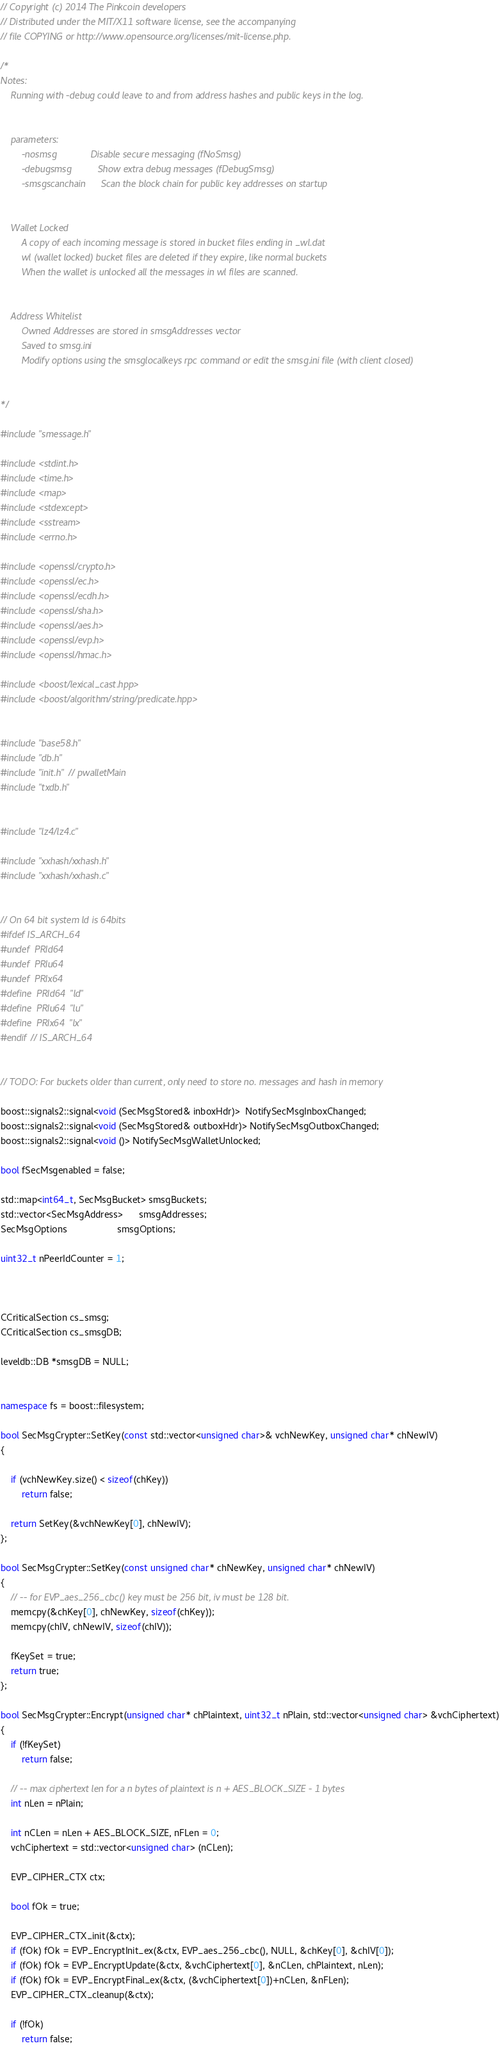<code> <loc_0><loc_0><loc_500><loc_500><_C++_>// Copyright (c) 2014 The Pinkcoin developers
// Distributed under the MIT/X11 software license, see the accompanying
// file COPYING or http://www.opensource.org/licenses/mit-license.php.

/*
Notes:
    Running with -debug could leave to and from address hashes and public keys in the log.
    
    
    parameters:
        -nosmsg             Disable secure messaging (fNoSmsg)
        -debugsmsg          Show extra debug messages (fDebugSmsg)
        -smsgscanchain      Scan the block chain for public key addresses on startup
    
    
    Wallet Locked
        A copy of each incoming message is stored in bucket files ending in _wl.dat
        wl (wallet locked) bucket files are deleted if they expire, like normal buckets
        When the wallet is unlocked all the messages in wl files are scanned.
    
    
    Address Whitelist
        Owned Addresses are stored in smsgAddresses vector
        Saved to smsg.ini
        Modify options using the smsglocalkeys rpc command or edit the smsg.ini file (with client closed)
        
    
*/

#include "smessage.h"

#include <stdint.h>
#include <time.h>
#include <map>
#include <stdexcept>
#include <sstream>
#include <errno.h>

#include <openssl/crypto.h>
#include <openssl/ec.h>
#include <openssl/ecdh.h>
#include <openssl/sha.h>
#include <openssl/aes.h>
#include <openssl/evp.h>
#include <openssl/hmac.h>

#include <boost/lexical_cast.hpp>
#include <boost/algorithm/string/predicate.hpp>


#include "base58.h"
#include "db.h"
#include "init.h" // pwalletMain
#include "txdb.h"


#include "lz4/lz4.c"

#include "xxhash/xxhash.h"
#include "xxhash/xxhash.c"


// On 64 bit system ld is 64bits
#ifdef IS_ARCH_64
#undef  PRId64
#undef  PRIu64
#undef  PRIx64
#define  PRId64  "ld"
#define  PRIu64  "lu"
#define  PRIx64  "lx"
#endif // IS_ARCH_64


// TODO: For buckets older than current, only need to store no. messages and hash in memory

boost::signals2::signal<void (SecMsgStored& inboxHdr)>  NotifySecMsgInboxChanged;
boost::signals2::signal<void (SecMsgStored& outboxHdr)> NotifySecMsgOutboxChanged;
boost::signals2::signal<void ()> NotifySecMsgWalletUnlocked;

bool fSecMsgenabled = false;

std::map<int64_t, SecMsgBucket> smsgBuckets;
std::vector<SecMsgAddress>      smsgAddresses;
SecMsgOptions                   smsgOptions;

uint32_t nPeerIdCounter = 1;



CCriticalSection cs_smsg;
CCriticalSection cs_smsgDB;

leveldb::DB *smsgDB = NULL;


namespace fs = boost::filesystem;

bool SecMsgCrypter::SetKey(const std::vector<unsigned char>& vchNewKey, unsigned char* chNewIV)
{
    
    if (vchNewKey.size() < sizeof(chKey))
        return false;
    
    return SetKey(&vchNewKey[0], chNewIV);
};

bool SecMsgCrypter::SetKey(const unsigned char* chNewKey, unsigned char* chNewIV)
{
    // -- for EVP_aes_256_cbc() key must be 256 bit, iv must be 128 bit.
    memcpy(&chKey[0], chNewKey, sizeof(chKey));
    memcpy(chIV, chNewIV, sizeof(chIV));
    
    fKeySet = true;
    return true;
};

bool SecMsgCrypter::Encrypt(unsigned char* chPlaintext, uint32_t nPlain, std::vector<unsigned char> &vchCiphertext)
{
    if (!fKeySet)
        return false;
    
    // -- max ciphertext len for a n bytes of plaintext is n + AES_BLOCK_SIZE - 1 bytes
    int nLen = nPlain;
    
    int nCLen = nLen + AES_BLOCK_SIZE, nFLen = 0;
    vchCiphertext = std::vector<unsigned char> (nCLen);

    EVP_CIPHER_CTX ctx;

    bool fOk = true;

    EVP_CIPHER_CTX_init(&ctx);
    if (fOk) fOk = EVP_EncryptInit_ex(&ctx, EVP_aes_256_cbc(), NULL, &chKey[0], &chIV[0]);
    if (fOk) fOk = EVP_EncryptUpdate(&ctx, &vchCiphertext[0], &nCLen, chPlaintext, nLen);
    if (fOk) fOk = EVP_EncryptFinal_ex(&ctx, (&vchCiphertext[0])+nCLen, &nFLen);
    EVP_CIPHER_CTX_cleanup(&ctx);

    if (!fOk)
        return false;
</code> 